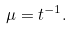Convert formula to latex. <formula><loc_0><loc_0><loc_500><loc_500>\mu = t ^ { - 1 } .</formula> 